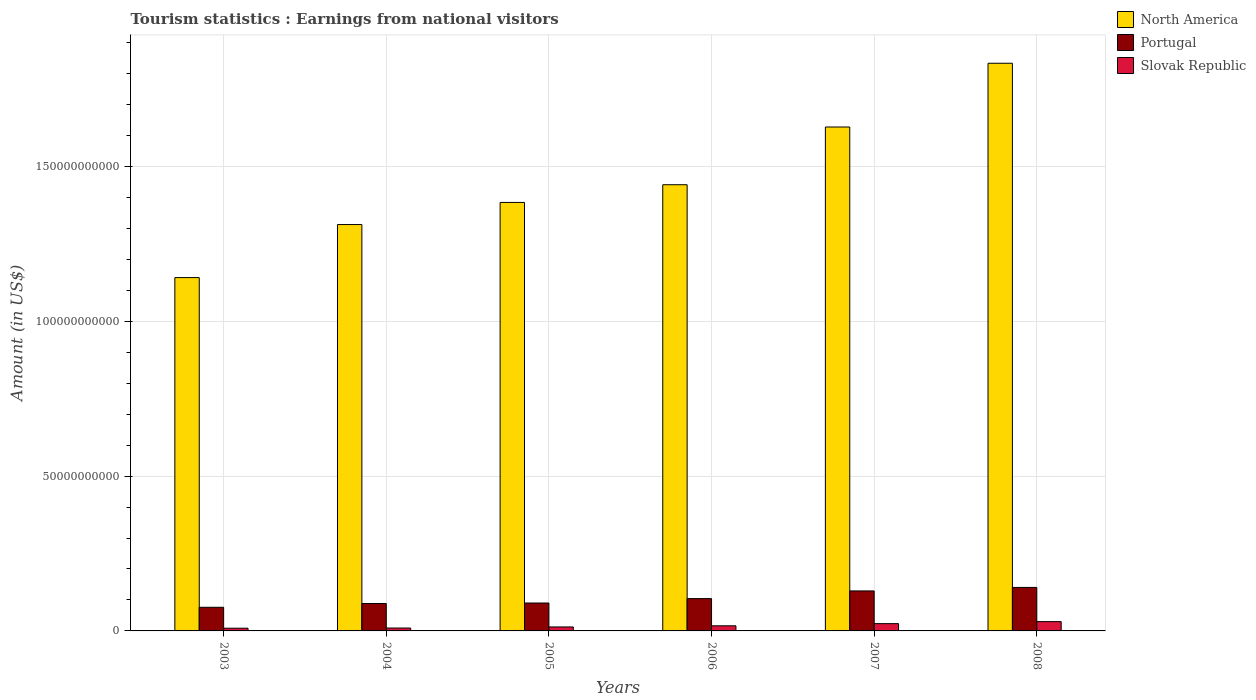How many different coloured bars are there?
Offer a terse response. 3. How many groups of bars are there?
Ensure brevity in your answer.  6. Are the number of bars on each tick of the X-axis equal?
Offer a very short reply. Yes. What is the earnings from national visitors in Portugal in 2003?
Provide a short and direct response. 7.63e+09. Across all years, what is the maximum earnings from national visitors in Slovak Republic?
Ensure brevity in your answer.  3.00e+09. Across all years, what is the minimum earnings from national visitors in North America?
Give a very brief answer. 1.14e+11. In which year was the earnings from national visitors in Portugal minimum?
Give a very brief answer. 2003. What is the total earnings from national visitors in Portugal in the graph?
Ensure brevity in your answer.  6.29e+1. What is the difference between the earnings from national visitors in North America in 2007 and that in 2008?
Your answer should be very brief. -2.06e+1. What is the difference between the earnings from national visitors in North America in 2003 and the earnings from national visitors in Portugal in 2006?
Ensure brevity in your answer.  1.04e+11. What is the average earnings from national visitors in North America per year?
Your answer should be very brief. 1.46e+11. In the year 2004, what is the difference between the earnings from national visitors in Slovak Republic and earnings from national visitors in North America?
Offer a very short reply. -1.30e+11. What is the ratio of the earnings from national visitors in North America in 2003 to that in 2005?
Ensure brevity in your answer.  0.82. Is the earnings from national visitors in Slovak Republic in 2006 less than that in 2007?
Ensure brevity in your answer.  Yes. What is the difference between the highest and the second highest earnings from national visitors in North America?
Give a very brief answer. 2.06e+1. What is the difference between the highest and the lowest earnings from national visitors in Portugal?
Provide a short and direct response. 6.41e+09. Is the sum of the earnings from national visitors in Portugal in 2004 and 2006 greater than the maximum earnings from national visitors in Slovak Republic across all years?
Give a very brief answer. Yes. What does the 1st bar from the right in 2008 represents?
Offer a terse response. Slovak Republic. Is it the case that in every year, the sum of the earnings from national visitors in Slovak Republic and earnings from national visitors in Portugal is greater than the earnings from national visitors in North America?
Keep it short and to the point. No. How many bars are there?
Offer a very short reply. 18. How many years are there in the graph?
Offer a terse response. 6. Are the values on the major ticks of Y-axis written in scientific E-notation?
Ensure brevity in your answer.  No. Does the graph contain grids?
Offer a very short reply. Yes. Where does the legend appear in the graph?
Offer a very short reply. Top right. How many legend labels are there?
Give a very brief answer. 3. What is the title of the graph?
Offer a very short reply. Tourism statistics : Earnings from national visitors. Does "Virgin Islands" appear as one of the legend labels in the graph?
Your response must be concise. No. What is the Amount (in US$) of North America in 2003?
Ensure brevity in your answer.  1.14e+11. What is the Amount (in US$) in Portugal in 2003?
Offer a terse response. 7.63e+09. What is the Amount (in US$) of Slovak Republic in 2003?
Ensure brevity in your answer.  8.76e+08. What is the Amount (in US$) in North America in 2004?
Provide a succinct answer. 1.31e+11. What is the Amount (in US$) of Portugal in 2004?
Provide a short and direct response. 8.86e+09. What is the Amount (in US$) of Slovak Republic in 2004?
Make the answer very short. 9.31e+08. What is the Amount (in US$) in North America in 2005?
Ensure brevity in your answer.  1.38e+11. What is the Amount (in US$) in Portugal in 2005?
Provide a short and direct response. 9.01e+09. What is the Amount (in US$) in Slovak Republic in 2005?
Ensure brevity in your answer.  1.28e+09. What is the Amount (in US$) in North America in 2006?
Keep it short and to the point. 1.44e+11. What is the Amount (in US$) in Portugal in 2006?
Ensure brevity in your answer.  1.04e+1. What is the Amount (in US$) of Slovak Republic in 2006?
Keep it short and to the point. 1.66e+09. What is the Amount (in US$) in North America in 2007?
Provide a succinct answer. 1.63e+11. What is the Amount (in US$) of Portugal in 2007?
Your answer should be compact. 1.29e+1. What is the Amount (in US$) in Slovak Republic in 2007?
Offer a very short reply. 2.35e+09. What is the Amount (in US$) of North America in 2008?
Make the answer very short. 1.83e+11. What is the Amount (in US$) of Portugal in 2008?
Your answer should be very brief. 1.40e+1. What is the Amount (in US$) of Slovak Republic in 2008?
Offer a very short reply. 3.00e+09. Across all years, what is the maximum Amount (in US$) of North America?
Your answer should be compact. 1.83e+11. Across all years, what is the maximum Amount (in US$) in Portugal?
Your answer should be compact. 1.40e+1. Across all years, what is the maximum Amount (in US$) of Slovak Republic?
Make the answer very short. 3.00e+09. Across all years, what is the minimum Amount (in US$) in North America?
Give a very brief answer. 1.14e+11. Across all years, what is the minimum Amount (in US$) in Portugal?
Provide a succinct answer. 7.63e+09. Across all years, what is the minimum Amount (in US$) in Slovak Republic?
Make the answer very short. 8.76e+08. What is the total Amount (in US$) in North America in the graph?
Offer a very short reply. 8.74e+11. What is the total Amount (in US$) in Portugal in the graph?
Offer a terse response. 6.29e+1. What is the total Amount (in US$) in Slovak Republic in the graph?
Your answer should be compact. 1.01e+1. What is the difference between the Amount (in US$) of North America in 2003 and that in 2004?
Provide a short and direct response. -1.71e+1. What is the difference between the Amount (in US$) in Portugal in 2003 and that in 2004?
Your answer should be compact. -1.22e+09. What is the difference between the Amount (in US$) in Slovak Republic in 2003 and that in 2004?
Your answer should be compact. -5.50e+07. What is the difference between the Amount (in US$) in North America in 2003 and that in 2005?
Keep it short and to the point. -2.43e+1. What is the difference between the Amount (in US$) of Portugal in 2003 and that in 2005?
Keep it short and to the point. -1.37e+09. What is the difference between the Amount (in US$) of Slovak Republic in 2003 and that in 2005?
Your response must be concise. -4.06e+08. What is the difference between the Amount (in US$) in North America in 2003 and that in 2006?
Your answer should be compact. -3.00e+1. What is the difference between the Amount (in US$) of Portugal in 2003 and that in 2006?
Give a very brief answer. -2.80e+09. What is the difference between the Amount (in US$) in Slovak Republic in 2003 and that in 2006?
Make the answer very short. -7.79e+08. What is the difference between the Amount (in US$) of North America in 2003 and that in 2007?
Your answer should be very brief. -4.86e+1. What is the difference between the Amount (in US$) in Portugal in 2003 and that in 2007?
Ensure brevity in your answer.  -5.28e+09. What is the difference between the Amount (in US$) of Slovak Republic in 2003 and that in 2007?
Your answer should be very brief. -1.48e+09. What is the difference between the Amount (in US$) of North America in 2003 and that in 2008?
Your answer should be very brief. -6.92e+1. What is the difference between the Amount (in US$) in Portugal in 2003 and that in 2008?
Your response must be concise. -6.41e+09. What is the difference between the Amount (in US$) of Slovak Republic in 2003 and that in 2008?
Make the answer very short. -2.13e+09. What is the difference between the Amount (in US$) of North America in 2004 and that in 2005?
Your response must be concise. -7.14e+09. What is the difference between the Amount (in US$) in Portugal in 2004 and that in 2005?
Make the answer very short. -1.50e+08. What is the difference between the Amount (in US$) of Slovak Republic in 2004 and that in 2005?
Provide a succinct answer. -3.51e+08. What is the difference between the Amount (in US$) of North America in 2004 and that in 2006?
Provide a succinct answer. -1.29e+1. What is the difference between the Amount (in US$) in Portugal in 2004 and that in 2006?
Offer a very short reply. -1.58e+09. What is the difference between the Amount (in US$) in Slovak Republic in 2004 and that in 2006?
Your response must be concise. -7.24e+08. What is the difference between the Amount (in US$) in North America in 2004 and that in 2007?
Ensure brevity in your answer.  -3.15e+1. What is the difference between the Amount (in US$) in Portugal in 2004 and that in 2007?
Provide a short and direct response. -4.06e+09. What is the difference between the Amount (in US$) in Slovak Republic in 2004 and that in 2007?
Provide a short and direct response. -1.42e+09. What is the difference between the Amount (in US$) in North America in 2004 and that in 2008?
Make the answer very short. -5.21e+1. What is the difference between the Amount (in US$) in Portugal in 2004 and that in 2008?
Your response must be concise. -5.19e+09. What is the difference between the Amount (in US$) in Slovak Republic in 2004 and that in 2008?
Provide a succinct answer. -2.07e+09. What is the difference between the Amount (in US$) in North America in 2005 and that in 2006?
Offer a terse response. -5.72e+09. What is the difference between the Amount (in US$) in Portugal in 2005 and that in 2006?
Provide a succinct answer. -1.43e+09. What is the difference between the Amount (in US$) in Slovak Republic in 2005 and that in 2006?
Provide a succinct answer. -3.73e+08. What is the difference between the Amount (in US$) in North America in 2005 and that in 2007?
Your answer should be very brief. -2.44e+1. What is the difference between the Amount (in US$) in Portugal in 2005 and that in 2007?
Make the answer very short. -3.91e+09. What is the difference between the Amount (in US$) in Slovak Republic in 2005 and that in 2007?
Offer a terse response. -1.07e+09. What is the difference between the Amount (in US$) of North America in 2005 and that in 2008?
Offer a very short reply. -4.50e+1. What is the difference between the Amount (in US$) of Portugal in 2005 and that in 2008?
Your answer should be very brief. -5.04e+09. What is the difference between the Amount (in US$) in Slovak Republic in 2005 and that in 2008?
Your answer should be very brief. -1.72e+09. What is the difference between the Amount (in US$) of North America in 2006 and that in 2007?
Offer a terse response. -1.86e+1. What is the difference between the Amount (in US$) in Portugal in 2006 and that in 2007?
Provide a short and direct response. -2.48e+09. What is the difference between the Amount (in US$) in Slovak Republic in 2006 and that in 2007?
Give a very brief answer. -6.97e+08. What is the difference between the Amount (in US$) in North America in 2006 and that in 2008?
Your response must be concise. -3.92e+1. What is the difference between the Amount (in US$) of Portugal in 2006 and that in 2008?
Your answer should be compact. -3.61e+09. What is the difference between the Amount (in US$) in Slovak Republic in 2006 and that in 2008?
Your response must be concise. -1.35e+09. What is the difference between the Amount (in US$) in North America in 2007 and that in 2008?
Ensure brevity in your answer.  -2.06e+1. What is the difference between the Amount (in US$) in Portugal in 2007 and that in 2008?
Your answer should be very brief. -1.13e+09. What is the difference between the Amount (in US$) in Slovak Republic in 2007 and that in 2008?
Keep it short and to the point. -6.52e+08. What is the difference between the Amount (in US$) of North America in 2003 and the Amount (in US$) of Portugal in 2004?
Provide a short and direct response. 1.05e+11. What is the difference between the Amount (in US$) in North America in 2003 and the Amount (in US$) in Slovak Republic in 2004?
Offer a very short reply. 1.13e+11. What is the difference between the Amount (in US$) of Portugal in 2003 and the Amount (in US$) of Slovak Republic in 2004?
Your answer should be very brief. 6.70e+09. What is the difference between the Amount (in US$) of North America in 2003 and the Amount (in US$) of Portugal in 2005?
Make the answer very short. 1.05e+11. What is the difference between the Amount (in US$) in North America in 2003 and the Amount (in US$) in Slovak Republic in 2005?
Provide a succinct answer. 1.13e+11. What is the difference between the Amount (in US$) in Portugal in 2003 and the Amount (in US$) in Slovak Republic in 2005?
Your answer should be very brief. 6.35e+09. What is the difference between the Amount (in US$) of North America in 2003 and the Amount (in US$) of Portugal in 2006?
Your response must be concise. 1.04e+11. What is the difference between the Amount (in US$) in North America in 2003 and the Amount (in US$) in Slovak Republic in 2006?
Your answer should be very brief. 1.12e+11. What is the difference between the Amount (in US$) in Portugal in 2003 and the Amount (in US$) in Slovak Republic in 2006?
Make the answer very short. 5.98e+09. What is the difference between the Amount (in US$) of North America in 2003 and the Amount (in US$) of Portugal in 2007?
Ensure brevity in your answer.  1.01e+11. What is the difference between the Amount (in US$) in North America in 2003 and the Amount (in US$) in Slovak Republic in 2007?
Keep it short and to the point. 1.12e+11. What is the difference between the Amount (in US$) of Portugal in 2003 and the Amount (in US$) of Slovak Republic in 2007?
Offer a terse response. 5.28e+09. What is the difference between the Amount (in US$) in North America in 2003 and the Amount (in US$) in Portugal in 2008?
Provide a succinct answer. 1.00e+11. What is the difference between the Amount (in US$) in North America in 2003 and the Amount (in US$) in Slovak Republic in 2008?
Give a very brief answer. 1.11e+11. What is the difference between the Amount (in US$) in Portugal in 2003 and the Amount (in US$) in Slovak Republic in 2008?
Provide a short and direct response. 4.63e+09. What is the difference between the Amount (in US$) in North America in 2004 and the Amount (in US$) in Portugal in 2005?
Make the answer very short. 1.22e+11. What is the difference between the Amount (in US$) of North America in 2004 and the Amount (in US$) of Slovak Republic in 2005?
Ensure brevity in your answer.  1.30e+11. What is the difference between the Amount (in US$) in Portugal in 2004 and the Amount (in US$) in Slovak Republic in 2005?
Your response must be concise. 7.58e+09. What is the difference between the Amount (in US$) in North America in 2004 and the Amount (in US$) in Portugal in 2006?
Give a very brief answer. 1.21e+11. What is the difference between the Amount (in US$) of North America in 2004 and the Amount (in US$) of Slovak Republic in 2006?
Provide a short and direct response. 1.30e+11. What is the difference between the Amount (in US$) in Portugal in 2004 and the Amount (in US$) in Slovak Republic in 2006?
Your answer should be very brief. 7.20e+09. What is the difference between the Amount (in US$) of North America in 2004 and the Amount (in US$) of Portugal in 2007?
Your answer should be very brief. 1.18e+11. What is the difference between the Amount (in US$) of North America in 2004 and the Amount (in US$) of Slovak Republic in 2007?
Keep it short and to the point. 1.29e+11. What is the difference between the Amount (in US$) of Portugal in 2004 and the Amount (in US$) of Slovak Republic in 2007?
Offer a very short reply. 6.51e+09. What is the difference between the Amount (in US$) of North America in 2004 and the Amount (in US$) of Portugal in 2008?
Offer a terse response. 1.17e+11. What is the difference between the Amount (in US$) in North America in 2004 and the Amount (in US$) in Slovak Republic in 2008?
Offer a very short reply. 1.28e+11. What is the difference between the Amount (in US$) in Portugal in 2004 and the Amount (in US$) in Slovak Republic in 2008?
Provide a short and direct response. 5.85e+09. What is the difference between the Amount (in US$) in North America in 2005 and the Amount (in US$) in Portugal in 2006?
Keep it short and to the point. 1.28e+11. What is the difference between the Amount (in US$) of North America in 2005 and the Amount (in US$) of Slovak Republic in 2006?
Ensure brevity in your answer.  1.37e+11. What is the difference between the Amount (in US$) of Portugal in 2005 and the Amount (in US$) of Slovak Republic in 2006?
Make the answer very short. 7.35e+09. What is the difference between the Amount (in US$) in North America in 2005 and the Amount (in US$) in Portugal in 2007?
Your response must be concise. 1.25e+11. What is the difference between the Amount (in US$) in North America in 2005 and the Amount (in US$) in Slovak Republic in 2007?
Your response must be concise. 1.36e+11. What is the difference between the Amount (in US$) of Portugal in 2005 and the Amount (in US$) of Slovak Republic in 2007?
Provide a succinct answer. 6.66e+09. What is the difference between the Amount (in US$) in North America in 2005 and the Amount (in US$) in Portugal in 2008?
Provide a short and direct response. 1.24e+11. What is the difference between the Amount (in US$) in North America in 2005 and the Amount (in US$) in Slovak Republic in 2008?
Your answer should be very brief. 1.35e+11. What is the difference between the Amount (in US$) in Portugal in 2005 and the Amount (in US$) in Slovak Republic in 2008?
Give a very brief answer. 6.00e+09. What is the difference between the Amount (in US$) in North America in 2006 and the Amount (in US$) in Portugal in 2007?
Provide a succinct answer. 1.31e+11. What is the difference between the Amount (in US$) in North America in 2006 and the Amount (in US$) in Slovak Republic in 2007?
Provide a succinct answer. 1.42e+11. What is the difference between the Amount (in US$) of Portugal in 2006 and the Amount (in US$) of Slovak Republic in 2007?
Keep it short and to the point. 8.09e+09. What is the difference between the Amount (in US$) of North America in 2006 and the Amount (in US$) of Portugal in 2008?
Ensure brevity in your answer.  1.30e+11. What is the difference between the Amount (in US$) of North America in 2006 and the Amount (in US$) of Slovak Republic in 2008?
Keep it short and to the point. 1.41e+11. What is the difference between the Amount (in US$) in Portugal in 2006 and the Amount (in US$) in Slovak Republic in 2008?
Keep it short and to the point. 7.43e+09. What is the difference between the Amount (in US$) in North America in 2007 and the Amount (in US$) in Portugal in 2008?
Your answer should be compact. 1.49e+11. What is the difference between the Amount (in US$) of North America in 2007 and the Amount (in US$) of Slovak Republic in 2008?
Provide a succinct answer. 1.60e+11. What is the difference between the Amount (in US$) in Portugal in 2007 and the Amount (in US$) in Slovak Republic in 2008?
Provide a short and direct response. 9.91e+09. What is the average Amount (in US$) of North America per year?
Offer a very short reply. 1.46e+11. What is the average Amount (in US$) of Portugal per year?
Ensure brevity in your answer.  1.05e+1. What is the average Amount (in US$) of Slovak Republic per year?
Keep it short and to the point. 1.68e+09. In the year 2003, what is the difference between the Amount (in US$) in North America and Amount (in US$) in Portugal?
Your response must be concise. 1.06e+11. In the year 2003, what is the difference between the Amount (in US$) in North America and Amount (in US$) in Slovak Republic?
Offer a very short reply. 1.13e+11. In the year 2003, what is the difference between the Amount (in US$) in Portugal and Amount (in US$) in Slovak Republic?
Give a very brief answer. 6.76e+09. In the year 2004, what is the difference between the Amount (in US$) in North America and Amount (in US$) in Portugal?
Provide a short and direct response. 1.22e+11. In the year 2004, what is the difference between the Amount (in US$) of North America and Amount (in US$) of Slovak Republic?
Give a very brief answer. 1.30e+11. In the year 2004, what is the difference between the Amount (in US$) of Portugal and Amount (in US$) of Slovak Republic?
Your answer should be very brief. 7.93e+09. In the year 2005, what is the difference between the Amount (in US$) in North America and Amount (in US$) in Portugal?
Provide a short and direct response. 1.29e+11. In the year 2005, what is the difference between the Amount (in US$) in North America and Amount (in US$) in Slovak Republic?
Make the answer very short. 1.37e+11. In the year 2005, what is the difference between the Amount (in US$) of Portugal and Amount (in US$) of Slovak Republic?
Ensure brevity in your answer.  7.73e+09. In the year 2006, what is the difference between the Amount (in US$) in North America and Amount (in US$) in Portugal?
Your answer should be compact. 1.34e+11. In the year 2006, what is the difference between the Amount (in US$) of North America and Amount (in US$) of Slovak Republic?
Provide a short and direct response. 1.42e+11. In the year 2006, what is the difference between the Amount (in US$) in Portugal and Amount (in US$) in Slovak Republic?
Provide a succinct answer. 8.78e+09. In the year 2007, what is the difference between the Amount (in US$) in North America and Amount (in US$) in Portugal?
Keep it short and to the point. 1.50e+11. In the year 2007, what is the difference between the Amount (in US$) in North America and Amount (in US$) in Slovak Republic?
Offer a very short reply. 1.60e+11. In the year 2007, what is the difference between the Amount (in US$) in Portugal and Amount (in US$) in Slovak Republic?
Give a very brief answer. 1.06e+1. In the year 2008, what is the difference between the Amount (in US$) of North America and Amount (in US$) of Portugal?
Offer a very short reply. 1.69e+11. In the year 2008, what is the difference between the Amount (in US$) of North America and Amount (in US$) of Slovak Republic?
Your response must be concise. 1.80e+11. In the year 2008, what is the difference between the Amount (in US$) of Portugal and Amount (in US$) of Slovak Republic?
Ensure brevity in your answer.  1.10e+1. What is the ratio of the Amount (in US$) of North America in 2003 to that in 2004?
Make the answer very short. 0.87. What is the ratio of the Amount (in US$) of Portugal in 2003 to that in 2004?
Your answer should be very brief. 0.86. What is the ratio of the Amount (in US$) of Slovak Republic in 2003 to that in 2004?
Provide a succinct answer. 0.94. What is the ratio of the Amount (in US$) in North America in 2003 to that in 2005?
Provide a short and direct response. 0.82. What is the ratio of the Amount (in US$) of Portugal in 2003 to that in 2005?
Offer a terse response. 0.85. What is the ratio of the Amount (in US$) in Slovak Republic in 2003 to that in 2005?
Your answer should be very brief. 0.68. What is the ratio of the Amount (in US$) in North America in 2003 to that in 2006?
Make the answer very short. 0.79. What is the ratio of the Amount (in US$) in Portugal in 2003 to that in 2006?
Provide a succinct answer. 0.73. What is the ratio of the Amount (in US$) of Slovak Republic in 2003 to that in 2006?
Your response must be concise. 0.53. What is the ratio of the Amount (in US$) of North America in 2003 to that in 2007?
Offer a very short reply. 0.7. What is the ratio of the Amount (in US$) in Portugal in 2003 to that in 2007?
Offer a very short reply. 0.59. What is the ratio of the Amount (in US$) in Slovak Republic in 2003 to that in 2007?
Give a very brief answer. 0.37. What is the ratio of the Amount (in US$) in North America in 2003 to that in 2008?
Ensure brevity in your answer.  0.62. What is the ratio of the Amount (in US$) in Portugal in 2003 to that in 2008?
Your response must be concise. 0.54. What is the ratio of the Amount (in US$) in Slovak Republic in 2003 to that in 2008?
Keep it short and to the point. 0.29. What is the ratio of the Amount (in US$) of North America in 2004 to that in 2005?
Keep it short and to the point. 0.95. What is the ratio of the Amount (in US$) in Portugal in 2004 to that in 2005?
Give a very brief answer. 0.98. What is the ratio of the Amount (in US$) of Slovak Republic in 2004 to that in 2005?
Your response must be concise. 0.73. What is the ratio of the Amount (in US$) in North America in 2004 to that in 2006?
Offer a terse response. 0.91. What is the ratio of the Amount (in US$) in Portugal in 2004 to that in 2006?
Offer a very short reply. 0.85. What is the ratio of the Amount (in US$) in Slovak Republic in 2004 to that in 2006?
Make the answer very short. 0.56. What is the ratio of the Amount (in US$) in North America in 2004 to that in 2007?
Your answer should be very brief. 0.81. What is the ratio of the Amount (in US$) in Portugal in 2004 to that in 2007?
Offer a terse response. 0.69. What is the ratio of the Amount (in US$) of Slovak Republic in 2004 to that in 2007?
Offer a terse response. 0.4. What is the ratio of the Amount (in US$) in North America in 2004 to that in 2008?
Offer a terse response. 0.72. What is the ratio of the Amount (in US$) in Portugal in 2004 to that in 2008?
Offer a very short reply. 0.63. What is the ratio of the Amount (in US$) in Slovak Republic in 2004 to that in 2008?
Your response must be concise. 0.31. What is the ratio of the Amount (in US$) in North America in 2005 to that in 2006?
Offer a very short reply. 0.96. What is the ratio of the Amount (in US$) of Portugal in 2005 to that in 2006?
Ensure brevity in your answer.  0.86. What is the ratio of the Amount (in US$) in Slovak Republic in 2005 to that in 2006?
Your response must be concise. 0.77. What is the ratio of the Amount (in US$) in North America in 2005 to that in 2007?
Your answer should be very brief. 0.85. What is the ratio of the Amount (in US$) in Portugal in 2005 to that in 2007?
Give a very brief answer. 0.7. What is the ratio of the Amount (in US$) of Slovak Republic in 2005 to that in 2007?
Provide a short and direct response. 0.55. What is the ratio of the Amount (in US$) of North America in 2005 to that in 2008?
Keep it short and to the point. 0.75. What is the ratio of the Amount (in US$) of Portugal in 2005 to that in 2008?
Provide a succinct answer. 0.64. What is the ratio of the Amount (in US$) in Slovak Republic in 2005 to that in 2008?
Your answer should be compact. 0.43. What is the ratio of the Amount (in US$) of North America in 2006 to that in 2007?
Provide a short and direct response. 0.89. What is the ratio of the Amount (in US$) of Portugal in 2006 to that in 2007?
Ensure brevity in your answer.  0.81. What is the ratio of the Amount (in US$) in Slovak Republic in 2006 to that in 2007?
Make the answer very short. 0.7. What is the ratio of the Amount (in US$) in North America in 2006 to that in 2008?
Give a very brief answer. 0.79. What is the ratio of the Amount (in US$) in Portugal in 2006 to that in 2008?
Ensure brevity in your answer.  0.74. What is the ratio of the Amount (in US$) in Slovak Republic in 2006 to that in 2008?
Provide a succinct answer. 0.55. What is the ratio of the Amount (in US$) of North America in 2007 to that in 2008?
Your answer should be compact. 0.89. What is the ratio of the Amount (in US$) in Portugal in 2007 to that in 2008?
Offer a very short reply. 0.92. What is the ratio of the Amount (in US$) of Slovak Republic in 2007 to that in 2008?
Offer a terse response. 0.78. What is the difference between the highest and the second highest Amount (in US$) in North America?
Give a very brief answer. 2.06e+1. What is the difference between the highest and the second highest Amount (in US$) in Portugal?
Your answer should be compact. 1.13e+09. What is the difference between the highest and the second highest Amount (in US$) of Slovak Republic?
Your answer should be compact. 6.52e+08. What is the difference between the highest and the lowest Amount (in US$) in North America?
Offer a terse response. 6.92e+1. What is the difference between the highest and the lowest Amount (in US$) of Portugal?
Your answer should be compact. 6.41e+09. What is the difference between the highest and the lowest Amount (in US$) in Slovak Republic?
Your answer should be very brief. 2.13e+09. 